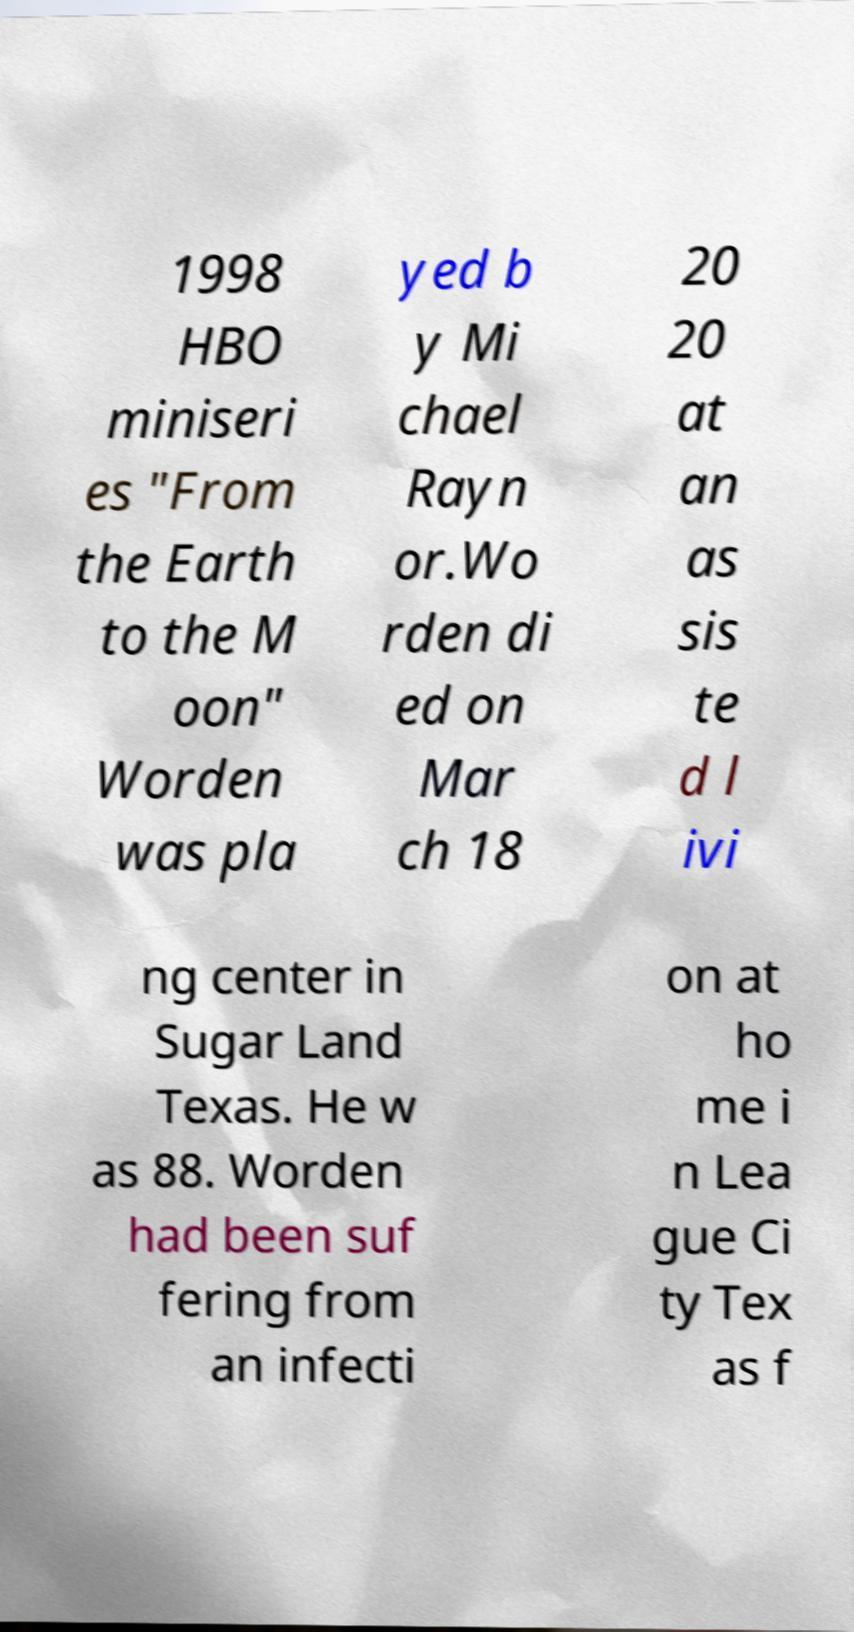Could you extract and type out the text from this image? 1998 HBO miniseri es "From the Earth to the M oon" Worden was pla yed b y Mi chael Rayn or.Wo rden di ed on Mar ch 18 20 20 at an as sis te d l ivi ng center in Sugar Land Texas. He w as 88. Worden had been suf fering from an infecti on at ho me i n Lea gue Ci ty Tex as f 